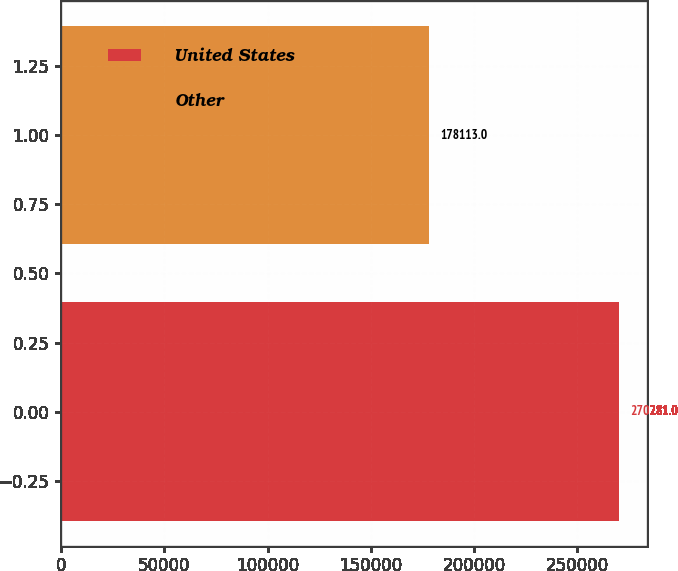Convert chart to OTSL. <chart><loc_0><loc_0><loc_500><loc_500><bar_chart><fcel>United States<fcel>Other<nl><fcel>270281<fcel>178113<nl></chart> 